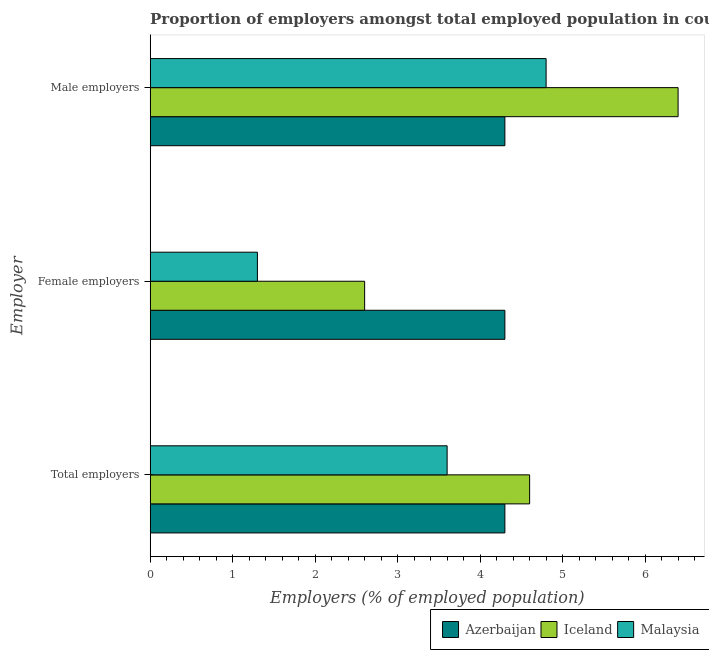How many groups of bars are there?
Make the answer very short. 3. Are the number of bars per tick equal to the number of legend labels?
Your answer should be very brief. Yes. How many bars are there on the 1st tick from the bottom?
Give a very brief answer. 3. What is the label of the 2nd group of bars from the top?
Your answer should be very brief. Female employers. What is the percentage of total employers in Malaysia?
Your answer should be compact. 3.6. Across all countries, what is the maximum percentage of male employers?
Provide a short and direct response. 6.4. Across all countries, what is the minimum percentage of female employers?
Your response must be concise. 1.3. In which country was the percentage of female employers maximum?
Offer a terse response. Azerbaijan. In which country was the percentage of total employers minimum?
Provide a succinct answer. Malaysia. What is the difference between the percentage of female employers in Iceland and that in Malaysia?
Keep it short and to the point. 1.3. What is the difference between the percentage of male employers in Azerbaijan and the percentage of female employers in Iceland?
Your answer should be compact. 1.7. What is the average percentage of female employers per country?
Provide a short and direct response. 2.73. What is the difference between the percentage of total employers and percentage of male employers in Malaysia?
Offer a very short reply. -1.2. In how many countries, is the percentage of total employers greater than 6.4 %?
Provide a short and direct response. 0. What is the ratio of the percentage of female employers in Malaysia to that in Azerbaijan?
Give a very brief answer. 0.3. What is the difference between the highest and the second highest percentage of female employers?
Ensure brevity in your answer.  1.7. What is the difference between the highest and the lowest percentage of female employers?
Your response must be concise. 3. In how many countries, is the percentage of female employers greater than the average percentage of female employers taken over all countries?
Your answer should be very brief. 1. What does the 3rd bar from the top in Total employers represents?
Make the answer very short. Azerbaijan. What does the 3rd bar from the bottom in Female employers represents?
Offer a very short reply. Malaysia. How many bars are there?
Keep it short and to the point. 9. Are all the bars in the graph horizontal?
Provide a short and direct response. Yes. How many countries are there in the graph?
Offer a terse response. 3. How many legend labels are there?
Provide a succinct answer. 3. How are the legend labels stacked?
Give a very brief answer. Horizontal. What is the title of the graph?
Make the answer very short. Proportion of employers amongst total employed population in countries. What is the label or title of the X-axis?
Your answer should be compact. Employers (% of employed population). What is the label or title of the Y-axis?
Make the answer very short. Employer. What is the Employers (% of employed population) in Azerbaijan in Total employers?
Make the answer very short. 4.3. What is the Employers (% of employed population) in Iceland in Total employers?
Offer a terse response. 4.6. What is the Employers (% of employed population) in Malaysia in Total employers?
Your answer should be compact. 3.6. What is the Employers (% of employed population) of Azerbaijan in Female employers?
Ensure brevity in your answer.  4.3. What is the Employers (% of employed population) of Iceland in Female employers?
Offer a very short reply. 2.6. What is the Employers (% of employed population) in Malaysia in Female employers?
Your answer should be very brief. 1.3. What is the Employers (% of employed population) of Azerbaijan in Male employers?
Your answer should be compact. 4.3. What is the Employers (% of employed population) of Iceland in Male employers?
Provide a succinct answer. 6.4. What is the Employers (% of employed population) of Malaysia in Male employers?
Provide a short and direct response. 4.8. Across all Employer, what is the maximum Employers (% of employed population) of Azerbaijan?
Offer a terse response. 4.3. Across all Employer, what is the maximum Employers (% of employed population) in Iceland?
Your answer should be very brief. 6.4. Across all Employer, what is the maximum Employers (% of employed population) in Malaysia?
Provide a short and direct response. 4.8. Across all Employer, what is the minimum Employers (% of employed population) in Azerbaijan?
Your response must be concise. 4.3. Across all Employer, what is the minimum Employers (% of employed population) of Iceland?
Ensure brevity in your answer.  2.6. Across all Employer, what is the minimum Employers (% of employed population) of Malaysia?
Give a very brief answer. 1.3. What is the total Employers (% of employed population) in Azerbaijan in the graph?
Your answer should be compact. 12.9. What is the total Employers (% of employed population) of Malaysia in the graph?
Provide a short and direct response. 9.7. What is the difference between the Employers (% of employed population) of Azerbaijan in Total employers and that in Male employers?
Ensure brevity in your answer.  0. What is the difference between the Employers (% of employed population) in Malaysia in Total employers and that in Male employers?
Ensure brevity in your answer.  -1.2. What is the difference between the Employers (% of employed population) of Azerbaijan in Female employers and that in Male employers?
Offer a very short reply. 0. What is the difference between the Employers (% of employed population) of Iceland in Female employers and that in Male employers?
Your answer should be compact. -3.8. What is the difference between the Employers (% of employed population) of Malaysia in Female employers and that in Male employers?
Offer a very short reply. -3.5. What is the difference between the Employers (% of employed population) in Azerbaijan in Total employers and the Employers (% of employed population) in Iceland in Female employers?
Offer a terse response. 1.7. What is the difference between the Employers (% of employed population) in Iceland in Total employers and the Employers (% of employed population) in Malaysia in Female employers?
Offer a terse response. 3.3. What is the difference between the Employers (% of employed population) of Azerbaijan in Total employers and the Employers (% of employed population) of Iceland in Male employers?
Provide a succinct answer. -2.1. What is the difference between the Employers (% of employed population) in Azerbaijan in Female employers and the Employers (% of employed population) in Malaysia in Male employers?
Offer a very short reply. -0.5. What is the difference between the Employers (% of employed population) in Iceland in Female employers and the Employers (% of employed population) in Malaysia in Male employers?
Provide a succinct answer. -2.2. What is the average Employers (% of employed population) of Iceland per Employer?
Offer a very short reply. 4.53. What is the average Employers (% of employed population) of Malaysia per Employer?
Provide a succinct answer. 3.23. What is the difference between the Employers (% of employed population) in Azerbaijan and Employers (% of employed population) in Iceland in Total employers?
Ensure brevity in your answer.  -0.3. What is the difference between the Employers (% of employed population) in Azerbaijan and Employers (% of employed population) in Malaysia in Total employers?
Keep it short and to the point. 0.7. What is the difference between the Employers (% of employed population) in Iceland and Employers (% of employed population) in Malaysia in Total employers?
Provide a succinct answer. 1. What is the difference between the Employers (% of employed population) of Azerbaijan and Employers (% of employed population) of Iceland in Female employers?
Give a very brief answer. 1.7. What is the difference between the Employers (% of employed population) in Azerbaijan and Employers (% of employed population) in Malaysia in Female employers?
Ensure brevity in your answer.  3. What is the difference between the Employers (% of employed population) of Azerbaijan and Employers (% of employed population) of Iceland in Male employers?
Your answer should be very brief. -2.1. What is the difference between the Employers (% of employed population) in Azerbaijan and Employers (% of employed population) in Malaysia in Male employers?
Provide a short and direct response. -0.5. What is the difference between the Employers (% of employed population) of Iceland and Employers (% of employed population) of Malaysia in Male employers?
Your answer should be very brief. 1.6. What is the ratio of the Employers (% of employed population) in Azerbaijan in Total employers to that in Female employers?
Offer a terse response. 1. What is the ratio of the Employers (% of employed population) in Iceland in Total employers to that in Female employers?
Keep it short and to the point. 1.77. What is the ratio of the Employers (% of employed population) in Malaysia in Total employers to that in Female employers?
Give a very brief answer. 2.77. What is the ratio of the Employers (% of employed population) of Iceland in Total employers to that in Male employers?
Offer a terse response. 0.72. What is the ratio of the Employers (% of employed population) in Malaysia in Total employers to that in Male employers?
Provide a short and direct response. 0.75. What is the ratio of the Employers (% of employed population) in Iceland in Female employers to that in Male employers?
Your answer should be very brief. 0.41. What is the ratio of the Employers (% of employed population) of Malaysia in Female employers to that in Male employers?
Offer a very short reply. 0.27. What is the difference between the highest and the lowest Employers (% of employed population) of Malaysia?
Keep it short and to the point. 3.5. 